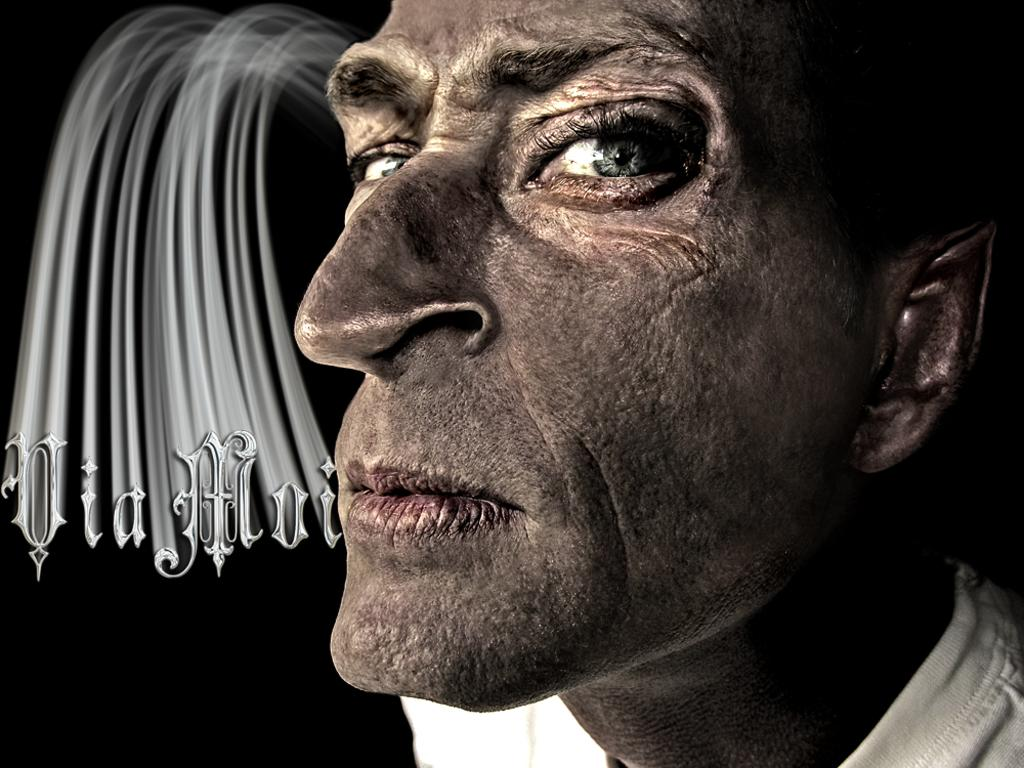What is the main object in the image? There is a poster in the image. What is depicted on the poster? The poster contains an image of a person. Are there any words on the poster? Yes, there is text on the poster. How would you describe the overall appearance of the image? The background of the image is dark. What type of shade is being used to protect the person on the poster from the sun? There is no shade present in the image, as it only features a poster with an image of a person and text. 